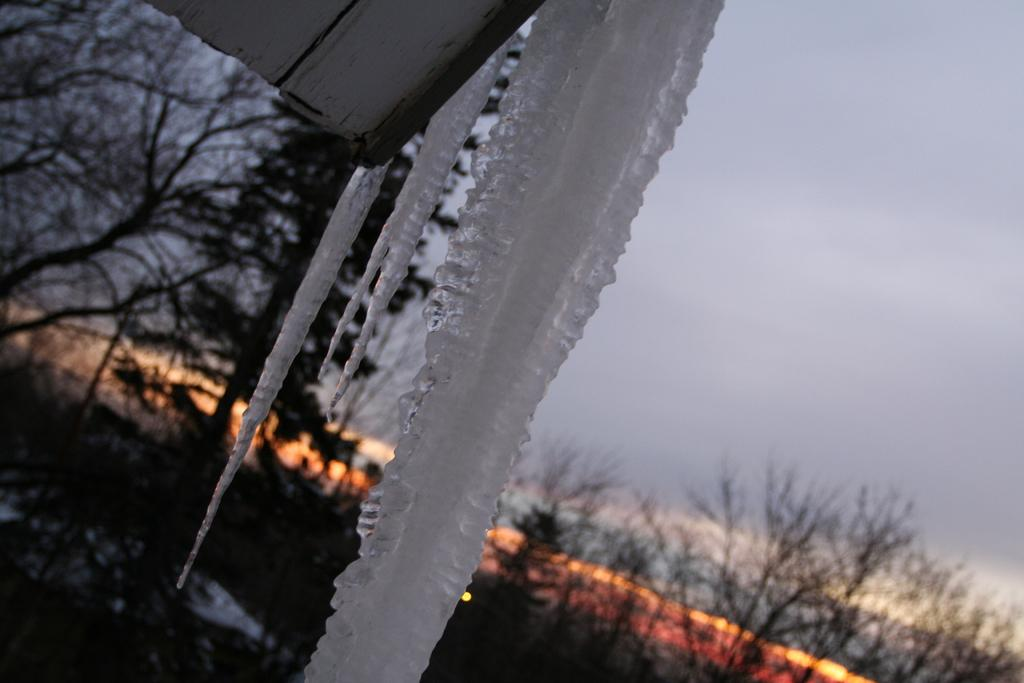What is the main subject of the image? The main subject of the image is an ice. What can be seen in the background of the image? There are dried trees in the background of the image. What colors are visible in the sky in the image? The sky is visible in the image, with a combination of white and orange colors. Is there a locket hanging from the ice in the image? There is no locket present in the image. Can you see any roofs in the image? There is no roof visible in the image; it primarily features an ice and dried trees in the background. 